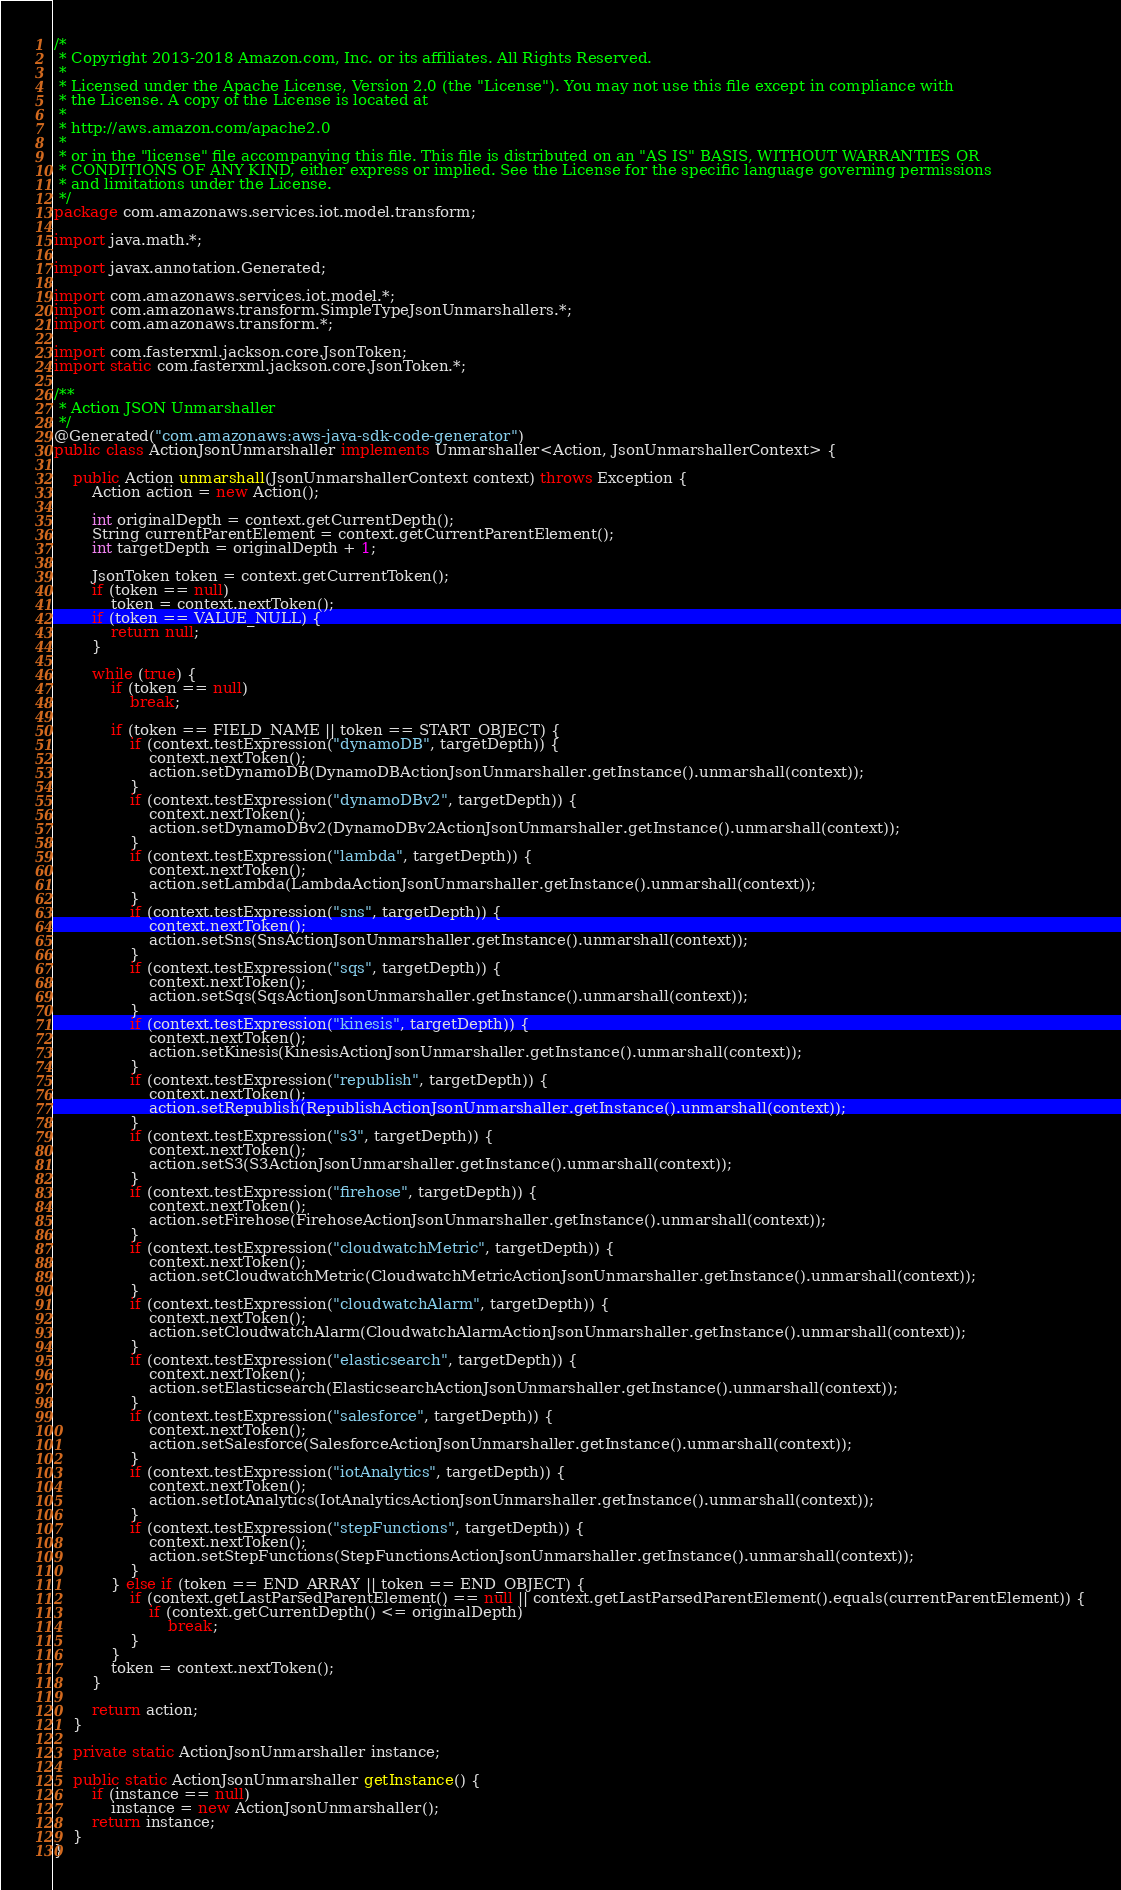Convert code to text. <code><loc_0><loc_0><loc_500><loc_500><_Java_>/*
 * Copyright 2013-2018 Amazon.com, Inc. or its affiliates. All Rights Reserved.
 * 
 * Licensed under the Apache License, Version 2.0 (the "License"). You may not use this file except in compliance with
 * the License. A copy of the License is located at
 * 
 * http://aws.amazon.com/apache2.0
 * 
 * or in the "license" file accompanying this file. This file is distributed on an "AS IS" BASIS, WITHOUT WARRANTIES OR
 * CONDITIONS OF ANY KIND, either express or implied. See the License for the specific language governing permissions
 * and limitations under the License.
 */
package com.amazonaws.services.iot.model.transform;

import java.math.*;

import javax.annotation.Generated;

import com.amazonaws.services.iot.model.*;
import com.amazonaws.transform.SimpleTypeJsonUnmarshallers.*;
import com.amazonaws.transform.*;

import com.fasterxml.jackson.core.JsonToken;
import static com.fasterxml.jackson.core.JsonToken.*;

/**
 * Action JSON Unmarshaller
 */
@Generated("com.amazonaws:aws-java-sdk-code-generator")
public class ActionJsonUnmarshaller implements Unmarshaller<Action, JsonUnmarshallerContext> {

    public Action unmarshall(JsonUnmarshallerContext context) throws Exception {
        Action action = new Action();

        int originalDepth = context.getCurrentDepth();
        String currentParentElement = context.getCurrentParentElement();
        int targetDepth = originalDepth + 1;

        JsonToken token = context.getCurrentToken();
        if (token == null)
            token = context.nextToken();
        if (token == VALUE_NULL) {
            return null;
        }

        while (true) {
            if (token == null)
                break;

            if (token == FIELD_NAME || token == START_OBJECT) {
                if (context.testExpression("dynamoDB", targetDepth)) {
                    context.nextToken();
                    action.setDynamoDB(DynamoDBActionJsonUnmarshaller.getInstance().unmarshall(context));
                }
                if (context.testExpression("dynamoDBv2", targetDepth)) {
                    context.nextToken();
                    action.setDynamoDBv2(DynamoDBv2ActionJsonUnmarshaller.getInstance().unmarshall(context));
                }
                if (context.testExpression("lambda", targetDepth)) {
                    context.nextToken();
                    action.setLambda(LambdaActionJsonUnmarshaller.getInstance().unmarshall(context));
                }
                if (context.testExpression("sns", targetDepth)) {
                    context.nextToken();
                    action.setSns(SnsActionJsonUnmarshaller.getInstance().unmarshall(context));
                }
                if (context.testExpression("sqs", targetDepth)) {
                    context.nextToken();
                    action.setSqs(SqsActionJsonUnmarshaller.getInstance().unmarshall(context));
                }
                if (context.testExpression("kinesis", targetDepth)) {
                    context.nextToken();
                    action.setKinesis(KinesisActionJsonUnmarshaller.getInstance().unmarshall(context));
                }
                if (context.testExpression("republish", targetDepth)) {
                    context.nextToken();
                    action.setRepublish(RepublishActionJsonUnmarshaller.getInstance().unmarshall(context));
                }
                if (context.testExpression("s3", targetDepth)) {
                    context.nextToken();
                    action.setS3(S3ActionJsonUnmarshaller.getInstance().unmarshall(context));
                }
                if (context.testExpression("firehose", targetDepth)) {
                    context.nextToken();
                    action.setFirehose(FirehoseActionJsonUnmarshaller.getInstance().unmarshall(context));
                }
                if (context.testExpression("cloudwatchMetric", targetDepth)) {
                    context.nextToken();
                    action.setCloudwatchMetric(CloudwatchMetricActionJsonUnmarshaller.getInstance().unmarshall(context));
                }
                if (context.testExpression("cloudwatchAlarm", targetDepth)) {
                    context.nextToken();
                    action.setCloudwatchAlarm(CloudwatchAlarmActionJsonUnmarshaller.getInstance().unmarshall(context));
                }
                if (context.testExpression("elasticsearch", targetDepth)) {
                    context.nextToken();
                    action.setElasticsearch(ElasticsearchActionJsonUnmarshaller.getInstance().unmarshall(context));
                }
                if (context.testExpression("salesforce", targetDepth)) {
                    context.nextToken();
                    action.setSalesforce(SalesforceActionJsonUnmarshaller.getInstance().unmarshall(context));
                }
                if (context.testExpression("iotAnalytics", targetDepth)) {
                    context.nextToken();
                    action.setIotAnalytics(IotAnalyticsActionJsonUnmarshaller.getInstance().unmarshall(context));
                }
                if (context.testExpression("stepFunctions", targetDepth)) {
                    context.nextToken();
                    action.setStepFunctions(StepFunctionsActionJsonUnmarshaller.getInstance().unmarshall(context));
                }
            } else if (token == END_ARRAY || token == END_OBJECT) {
                if (context.getLastParsedParentElement() == null || context.getLastParsedParentElement().equals(currentParentElement)) {
                    if (context.getCurrentDepth() <= originalDepth)
                        break;
                }
            }
            token = context.nextToken();
        }

        return action;
    }

    private static ActionJsonUnmarshaller instance;

    public static ActionJsonUnmarshaller getInstance() {
        if (instance == null)
            instance = new ActionJsonUnmarshaller();
        return instance;
    }
}
</code> 